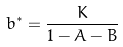Convert formula to latex. <formula><loc_0><loc_0><loc_500><loc_500>b ^ { * } = \frac { K } { 1 - A - B }</formula> 